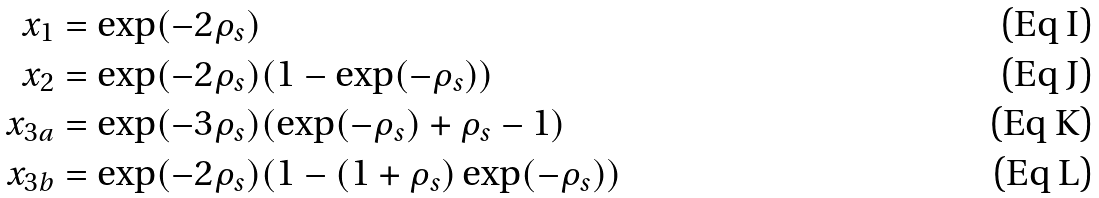<formula> <loc_0><loc_0><loc_500><loc_500>x _ { 1 } & = \exp ( - 2 \rho _ { s } ) \\ x _ { 2 } & = \exp ( - 2 \rho _ { s } ) ( 1 - \exp ( - \rho _ { s } ) ) \\ x _ { 3 a } & = \exp ( - 3 \rho _ { s } ) ( \exp ( - \rho _ { s } ) + \rho _ { s } - 1 ) \\ x _ { 3 b } & = \exp ( - 2 \rho _ { s } ) ( 1 - ( 1 + \rho _ { s } ) \exp ( - \rho _ { s } ) )</formula> 